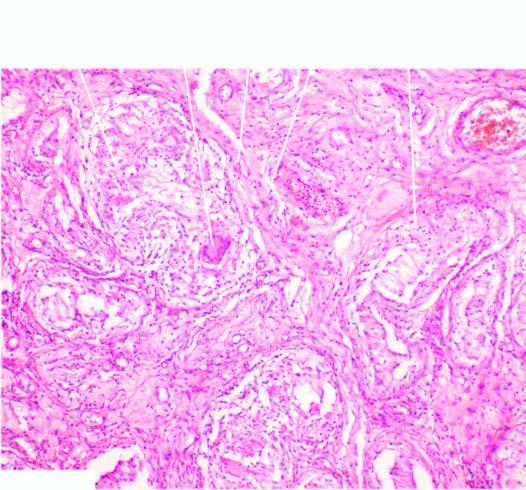does wide base contain several epithelioid cell granulomas with central areas of caseation necrosis?
Answer the question using a single word or phrase. No 